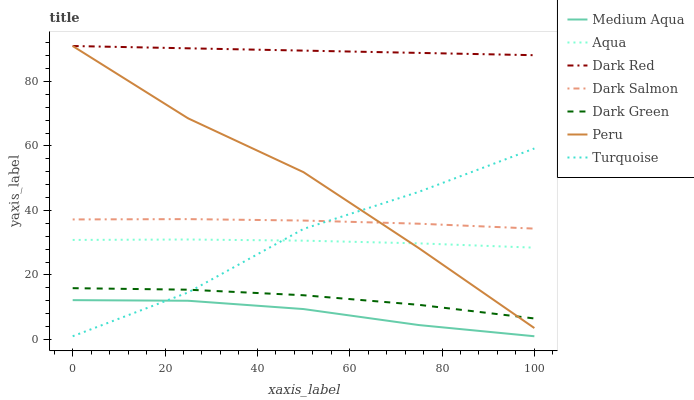Does Medium Aqua have the minimum area under the curve?
Answer yes or no. Yes. Does Dark Red have the maximum area under the curve?
Answer yes or no. Yes. Does Aqua have the minimum area under the curve?
Answer yes or no. No. Does Aqua have the maximum area under the curve?
Answer yes or no. No. Is Dark Red the smoothest?
Answer yes or no. Yes. Is Turquoise the roughest?
Answer yes or no. Yes. Is Aqua the smoothest?
Answer yes or no. No. Is Aqua the roughest?
Answer yes or no. No. Does Turquoise have the lowest value?
Answer yes or no. Yes. Does Aqua have the lowest value?
Answer yes or no. No. Does Peru have the highest value?
Answer yes or no. Yes. Does Aqua have the highest value?
Answer yes or no. No. Is Medium Aqua less than Peru?
Answer yes or no. Yes. Is Peru greater than Medium Aqua?
Answer yes or no. Yes. Does Dark Salmon intersect Turquoise?
Answer yes or no. Yes. Is Dark Salmon less than Turquoise?
Answer yes or no. No. Is Dark Salmon greater than Turquoise?
Answer yes or no. No. Does Medium Aqua intersect Peru?
Answer yes or no. No. 